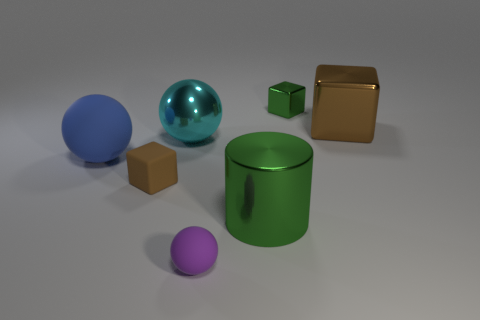Add 1 small brown cylinders. How many objects exist? 8 Subtract all spheres. How many objects are left? 4 Add 1 large cubes. How many large cubes are left? 2 Add 4 blue things. How many blue things exist? 5 Subtract 1 blue spheres. How many objects are left? 6 Subtract all matte objects. Subtract all green metal objects. How many objects are left? 2 